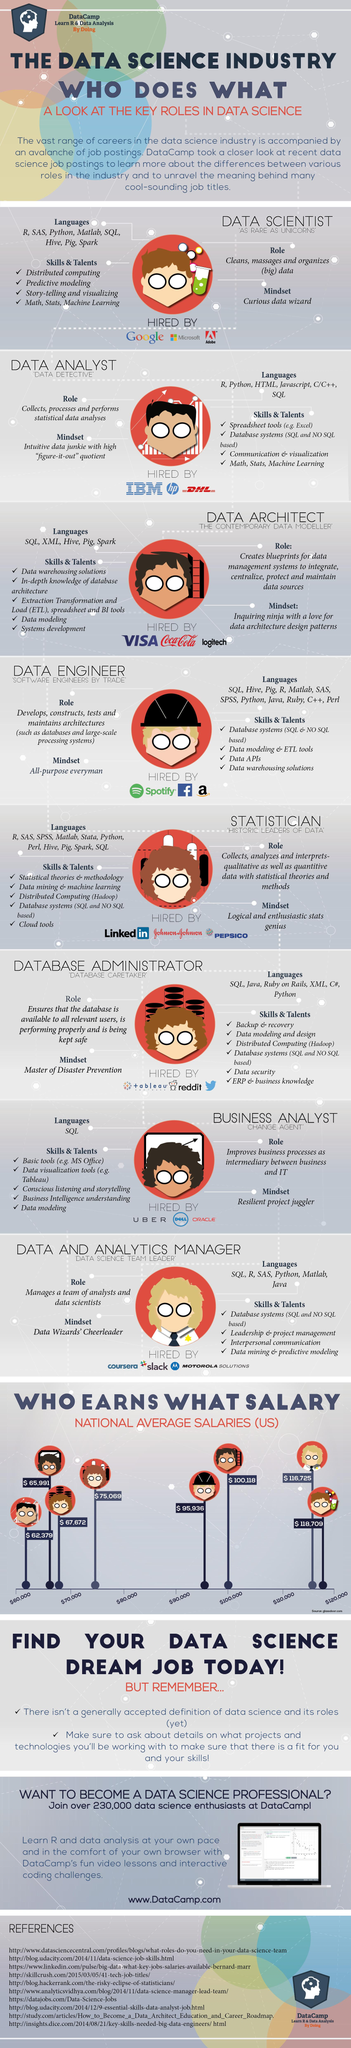Point out several critical features in this image. The job of data scientist in the United States data science industry has the highest average salary. The job with the lowest average salary in the data science industry in the U.S. is a data analyst. A business analyst in the data science industry should possess a resilient and adaptable mindset, with the ability to effectively juggle multiple projects and prioritize tasks to ensure successful project outcomes. According to data, the national average salary for a business analyst role in the U.S. data science industry is $65,991. IBM, HP, and DHL are companies that have hired for data analyst roles in the United States. 